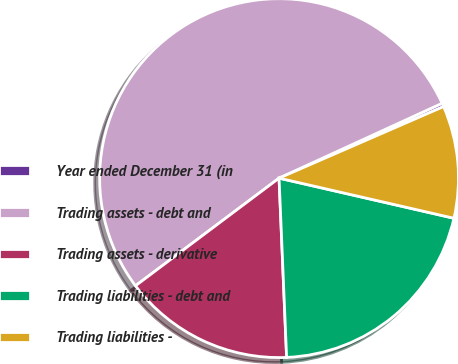Convert chart to OTSL. <chart><loc_0><loc_0><loc_500><loc_500><pie_chart><fcel>Year ended December 31 (in<fcel>Trading assets - debt and<fcel>Trading assets - derivative<fcel>Trading liabilities - debt and<fcel>Trading liabilities -<nl><fcel>0.32%<fcel>53.39%<fcel>15.43%<fcel>20.74%<fcel>10.12%<nl></chart> 